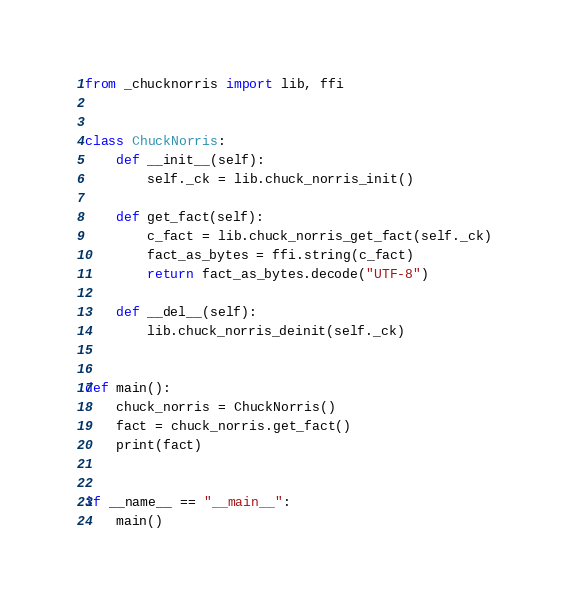Convert code to text. <code><loc_0><loc_0><loc_500><loc_500><_Python_>from _chucknorris import lib, ffi


class ChuckNorris:
    def __init__(self):
        self._ck = lib.chuck_norris_init()

    def get_fact(self):
        c_fact = lib.chuck_norris_get_fact(self._ck)
        fact_as_bytes = ffi.string(c_fact)
        return fact_as_bytes.decode("UTF-8")

    def __del__(self):
        lib.chuck_norris_deinit(self._ck)


def main():
    chuck_norris = ChuckNorris()
    fact = chuck_norris.get_fact()
    print(fact)


if __name__ == "__main__":
    main()

</code> 